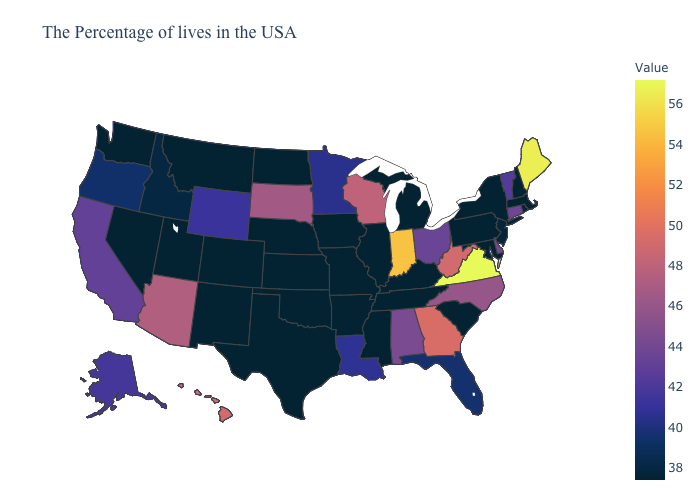Among the states that border Georgia , which have the highest value?
Keep it brief. North Carolina. Among the states that border Wisconsin , which have the highest value?
Short answer required. Minnesota. Does Kentucky have a higher value than Minnesota?
Give a very brief answer. No. Among the states that border Indiana , does Illinois have the highest value?
Be succinct. No. Which states have the lowest value in the USA?
Give a very brief answer. Massachusetts, Rhode Island, New Hampshire, New York, Maryland, Pennsylvania, South Carolina, Michigan, Kentucky, Tennessee, Illinois, Mississippi, Missouri, Arkansas, Iowa, Kansas, Nebraska, Oklahoma, Texas, North Dakota, Colorado, New Mexico, Utah, Montana, Nevada, Washington. Does Oklahoma have a higher value than Ohio?
Concise answer only. No. 